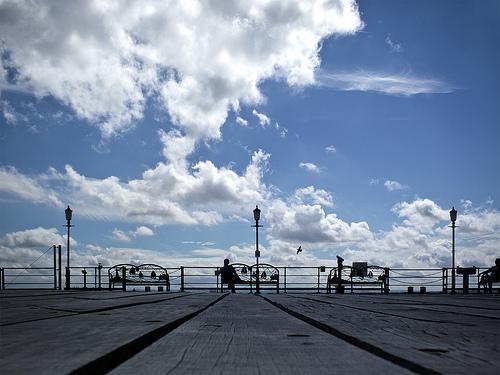How many people are in the photo?
Give a very brief answer. 1. 